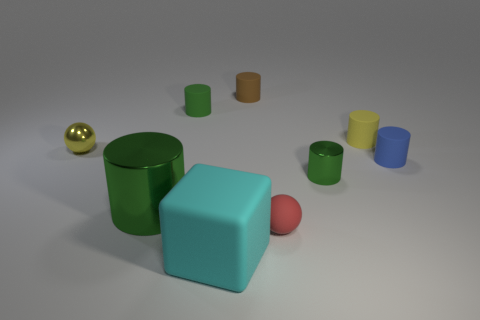Is there a green matte thing of the same shape as the tiny brown rubber object?
Offer a terse response. Yes. What is the color of the metal ball that is the same size as the yellow cylinder?
Your answer should be compact. Yellow. How many objects are either shiny objects left of the big cyan rubber block or tiny rubber cylinders on the left side of the blue matte cylinder?
Keep it short and to the point. 5. How many objects are either small red rubber objects or big metal balls?
Provide a succinct answer. 1. What size is the cylinder that is both left of the tiny brown cylinder and behind the blue cylinder?
Your answer should be compact. Small. How many small yellow cylinders are the same material as the small brown thing?
Ensure brevity in your answer.  1. The ball that is made of the same material as the blue cylinder is what color?
Provide a short and direct response. Red. Do the big object that is behind the small red rubber ball and the large cube have the same color?
Ensure brevity in your answer.  No. There is a small sphere that is left of the tiny red ball; what is its material?
Ensure brevity in your answer.  Metal. Is the number of blue rubber things on the left side of the small rubber ball the same as the number of yellow objects?
Ensure brevity in your answer.  No. 